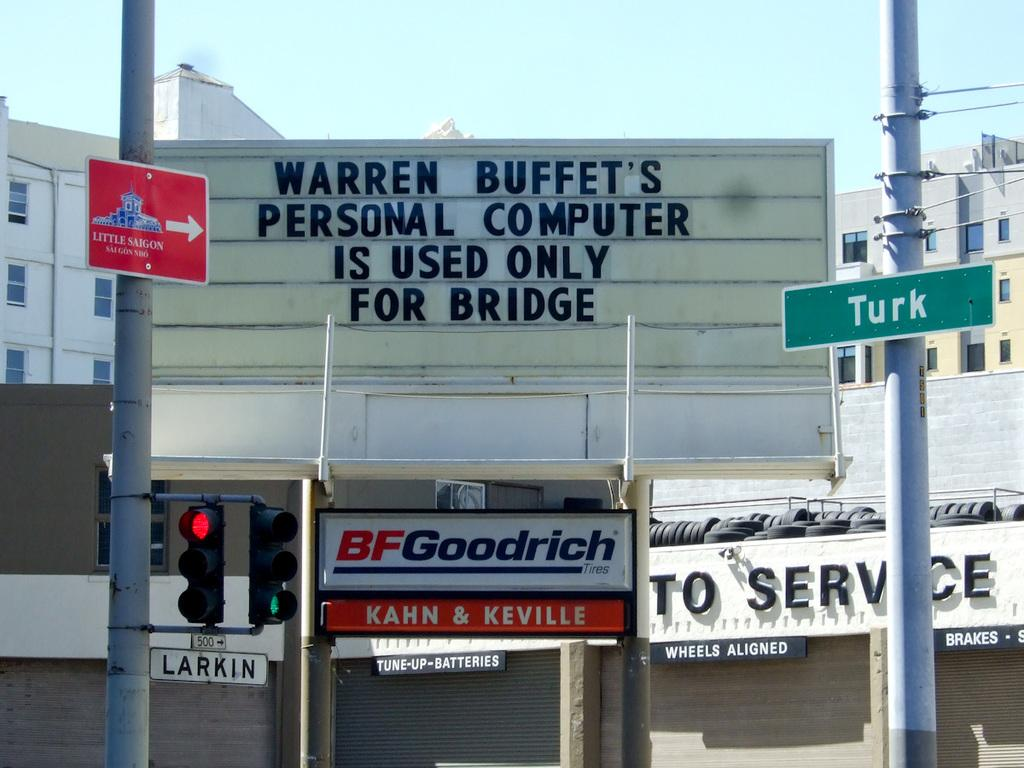What type of structures are present in the image? There are buildings with boards in the image. What is written on the boards? There is text on the boards. Can you describe the poles with boards in the image? There are poles with boards on the left and right sides of the image. What can be seen in the background of the image? The sky is visible at the top of the image. How many fowl are perched on the boards in the image? There are no fowl present in the image; the boards contain text. What type of calculations can be performed using the calculator in the image? There is no calculator present in the image. 